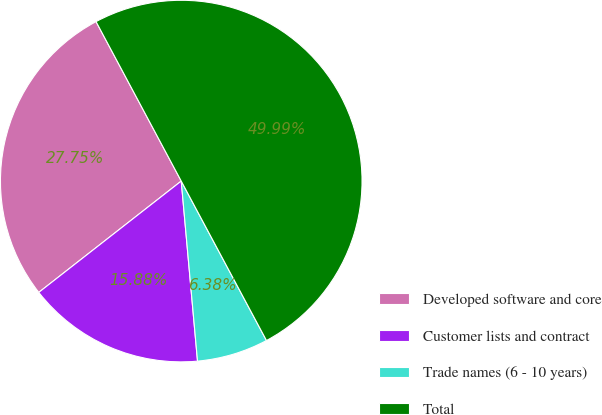Convert chart. <chart><loc_0><loc_0><loc_500><loc_500><pie_chart><fcel>Developed software and core<fcel>Customer lists and contract<fcel>Trade names (6 - 10 years)<fcel>Total<nl><fcel>27.75%<fcel>15.88%<fcel>6.38%<fcel>50.0%<nl></chart> 